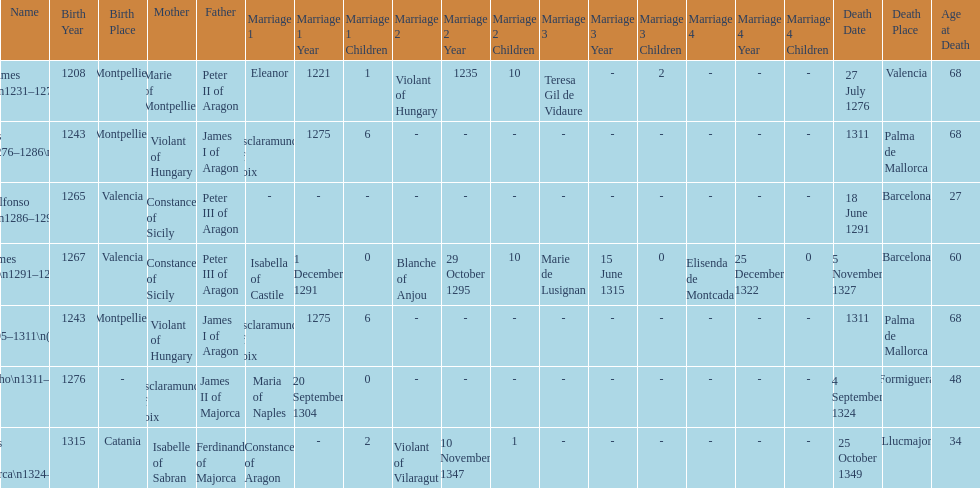Was james iii or sancho born in the year 1276? Sancho. 